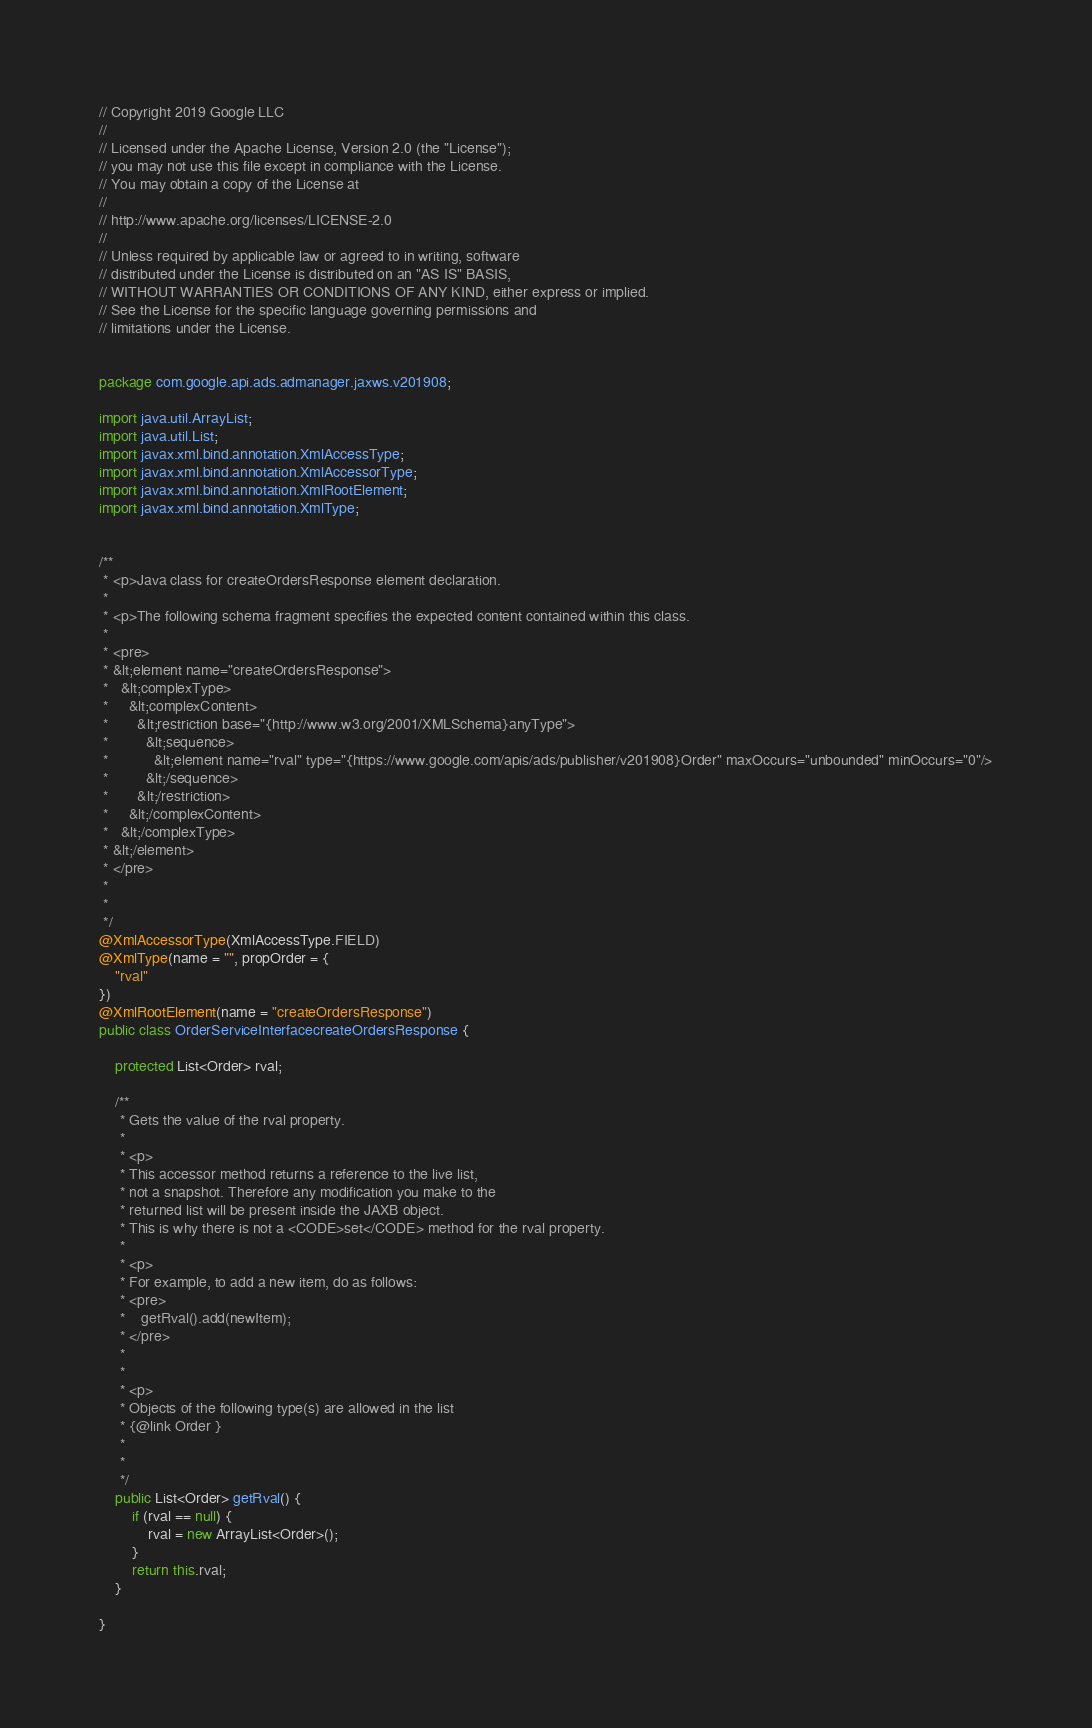Convert code to text. <code><loc_0><loc_0><loc_500><loc_500><_Java_>// Copyright 2019 Google LLC
//
// Licensed under the Apache License, Version 2.0 (the "License");
// you may not use this file except in compliance with the License.
// You may obtain a copy of the License at
//
// http://www.apache.org/licenses/LICENSE-2.0
//
// Unless required by applicable law or agreed to in writing, software
// distributed under the License is distributed on an "AS IS" BASIS,
// WITHOUT WARRANTIES OR CONDITIONS OF ANY KIND, either express or implied.
// See the License for the specific language governing permissions and
// limitations under the License.


package com.google.api.ads.admanager.jaxws.v201908;

import java.util.ArrayList;
import java.util.List;
import javax.xml.bind.annotation.XmlAccessType;
import javax.xml.bind.annotation.XmlAccessorType;
import javax.xml.bind.annotation.XmlRootElement;
import javax.xml.bind.annotation.XmlType;


/**
 * <p>Java class for createOrdersResponse element declaration.
 * 
 * <p>The following schema fragment specifies the expected content contained within this class.
 * 
 * <pre>
 * &lt;element name="createOrdersResponse">
 *   &lt;complexType>
 *     &lt;complexContent>
 *       &lt;restriction base="{http://www.w3.org/2001/XMLSchema}anyType">
 *         &lt;sequence>
 *           &lt;element name="rval" type="{https://www.google.com/apis/ads/publisher/v201908}Order" maxOccurs="unbounded" minOccurs="0"/>
 *         &lt;/sequence>
 *       &lt;/restriction>
 *     &lt;/complexContent>
 *   &lt;/complexType>
 * &lt;/element>
 * </pre>
 * 
 * 
 */
@XmlAccessorType(XmlAccessType.FIELD)
@XmlType(name = "", propOrder = {
    "rval"
})
@XmlRootElement(name = "createOrdersResponse")
public class OrderServiceInterfacecreateOrdersResponse {

    protected List<Order> rval;

    /**
     * Gets the value of the rval property.
     * 
     * <p>
     * This accessor method returns a reference to the live list,
     * not a snapshot. Therefore any modification you make to the
     * returned list will be present inside the JAXB object.
     * This is why there is not a <CODE>set</CODE> method for the rval property.
     * 
     * <p>
     * For example, to add a new item, do as follows:
     * <pre>
     *    getRval().add(newItem);
     * </pre>
     * 
     * 
     * <p>
     * Objects of the following type(s) are allowed in the list
     * {@link Order }
     * 
     * 
     */
    public List<Order> getRval() {
        if (rval == null) {
            rval = new ArrayList<Order>();
        }
        return this.rval;
    }

}
</code> 